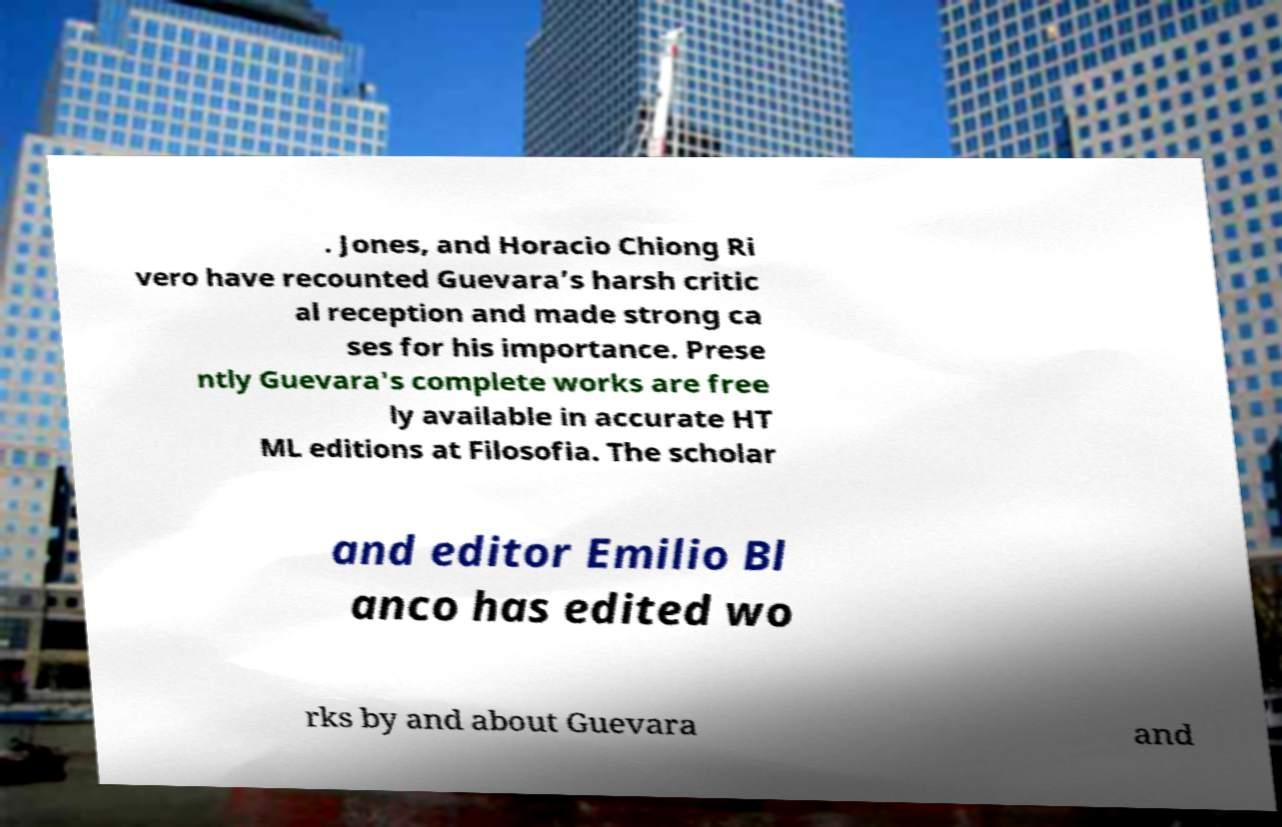What messages or text are displayed in this image? I need them in a readable, typed format. . Jones, and Horacio Chiong Ri vero have recounted Guevara’s harsh critic al reception and made strong ca ses for his importance. Prese ntly Guevara's complete works are free ly available in accurate HT ML editions at Filosofia. The scholar and editor Emilio Bl anco has edited wo rks by and about Guevara and 